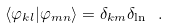<formula> <loc_0><loc_0><loc_500><loc_500>\langle \varphi _ { k l } | \varphi _ { m n } \rangle = \delta _ { k m } \delta _ { \ln } \ .</formula> 